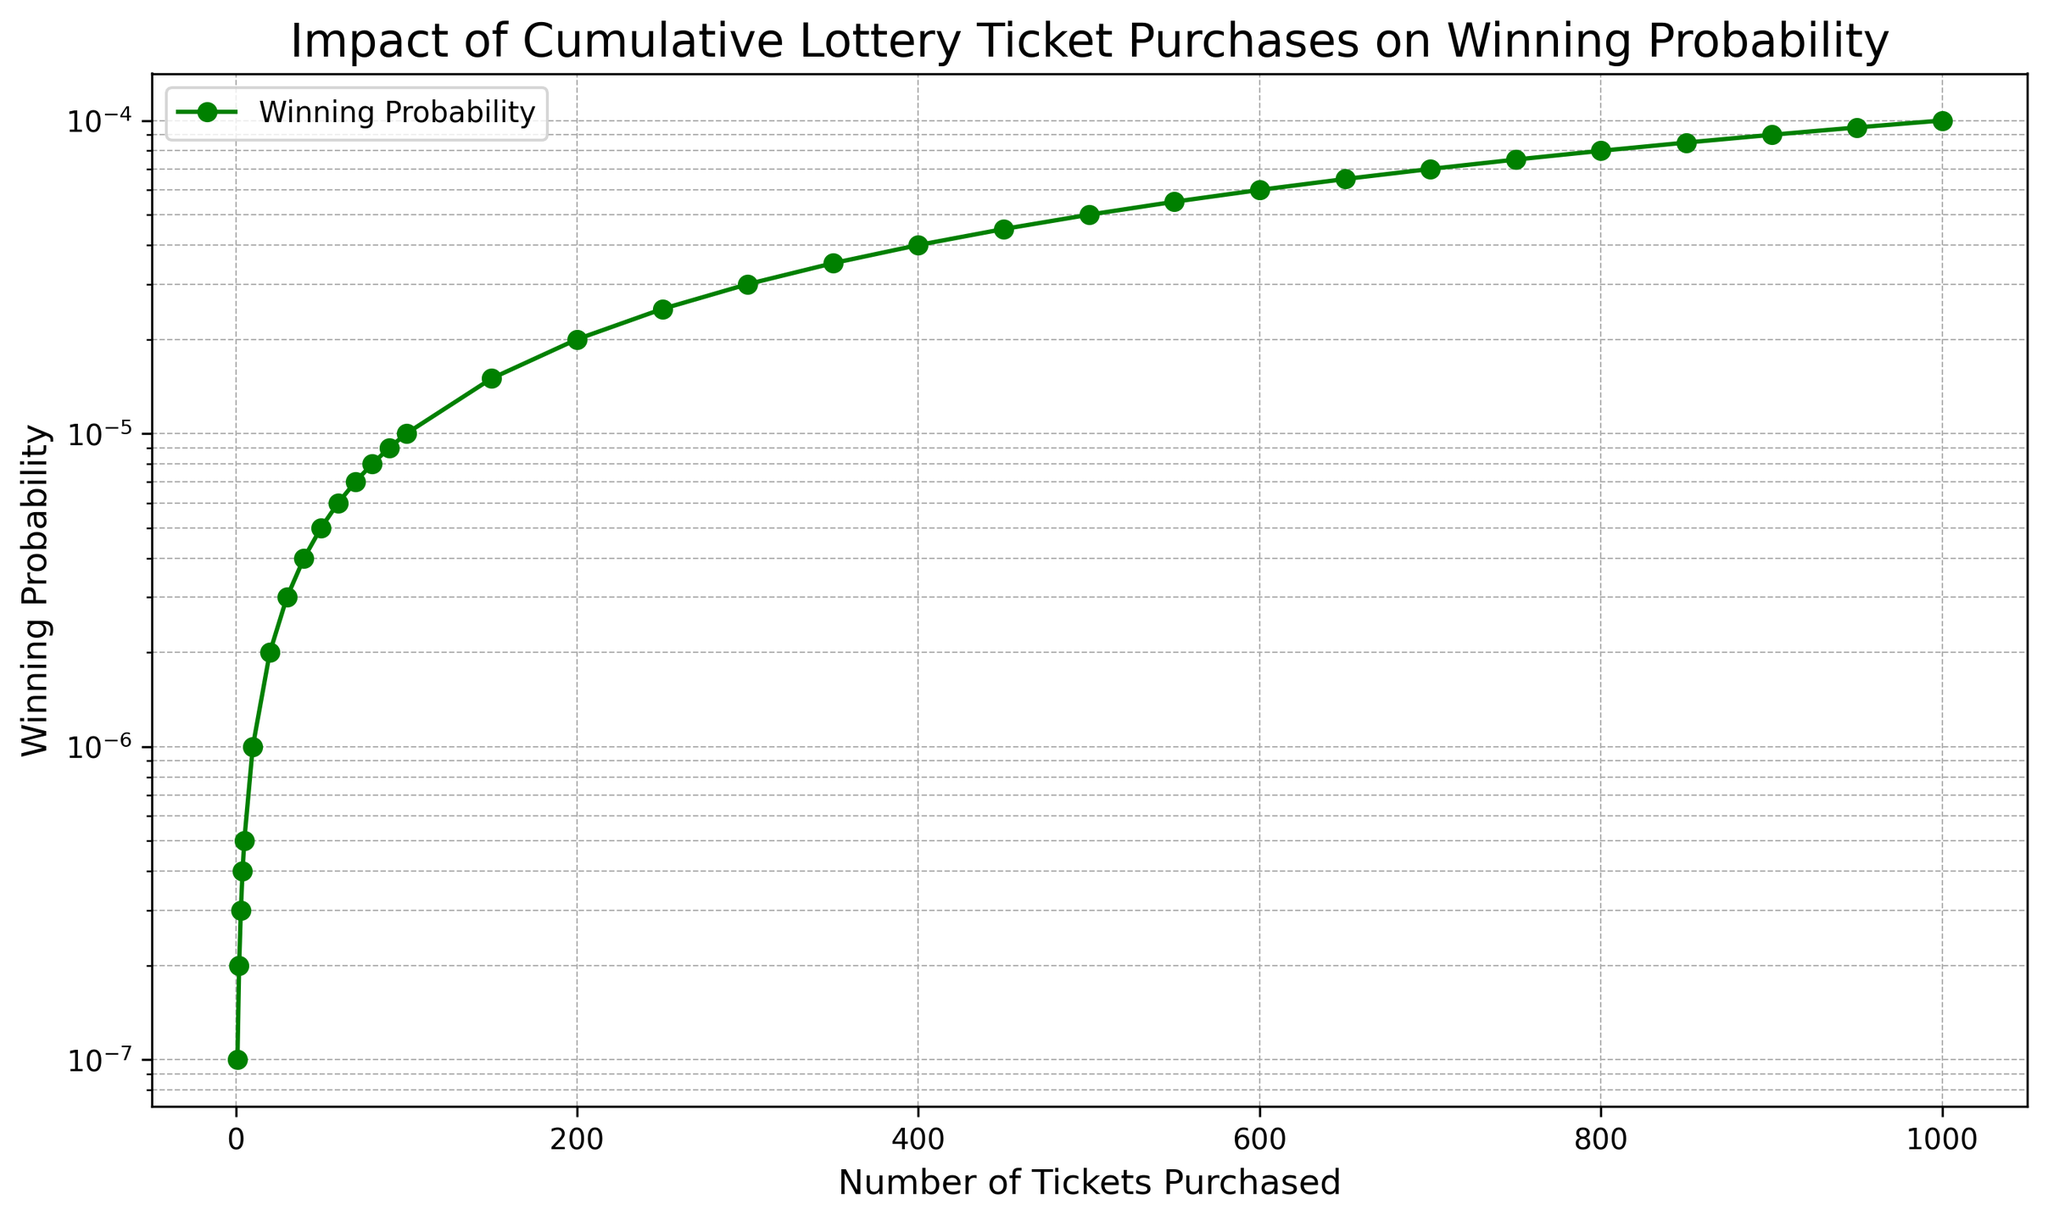What's the probability of winning if 500 tickets are purchased? The y-axis shows the winning probability, and the x-axis shows the number of tickets purchased. Locate the point where x=500, then look at the corresponding y-value which is 5e-5.
Answer: 5e-5 Comparing the probability of winning for 50 tickets to 100 tickets, which is higher and by how much? The plot shows the winning probabilities as increasing with the number of tickets. For 50 tickets, the probability is 5e-6. For 100 tickets, it is 1e-5. The increase in probability from 50 to 100 tickets is 1e-5 - 5e-6 = 5e-6.
Answer: 1e-5 is higher by 5e-6 What is the trend in winning probability as more tickets are purchased? The plot shows a steady upward trend in the winning probability as the number of tickets increases. This visual trend demonstrates that buying more tickets increases the chance of winning.
Answer: Increases If someone buys 300 tickets, how does the winning probability compare to buying 150 tickets? Find the winning probabilities for 300 and 150 tickets on the graph. For 300 tickets, the probability is 3e-5, and for 150 tickets, it is 1.5e-5. To compare, 3e-5 is double 1.5e-5.
Answer: 3e-5 is double What can you infer about winning probability from the green line's slope on the plot? The green line represents the winning probability, and its positive slope indicates that as the number of tickets purchased increases, the winning probability also increases.
Answer: Winning probability increases How many tickets must be purchased to achieve a winning probability of 2e-5? On the y-axis, locate the probability value of 2e-5 and trace it to where it intersects the green line and then down to the x-axis which corresponds to about 200 tickets.
Answer: 200 tickets Is the relationship between the number of tickets purchased and the winning probability linear or exponential? The plot shows a relatively linear increase in the winning probability as the number of tickets increases, denoted by the straight green line on the graph.
Answer: Linear Based on the figure, what is the winning probability if 850 tickets are bought? Locate the point where the x-axis value is 850 and follow vertically to intersect the green line. The corresponding y-axis value is 8.5e-5.
Answer: 8.5e-5 